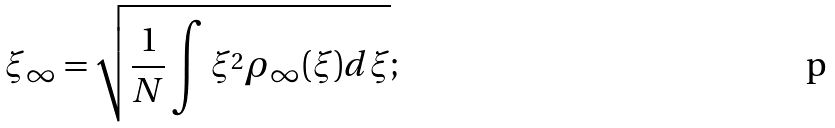<formula> <loc_0><loc_0><loc_500><loc_500>\xi _ { \infty } = \sqrt { \frac { 1 } { N } \int \xi ^ { 2 } \rho _ { \infty } ( \xi ) d \xi } ;</formula> 